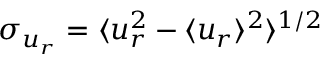<formula> <loc_0><loc_0><loc_500><loc_500>\sigma _ { u _ { r } } = \langle u _ { r } ^ { 2 } - \langle u _ { r } \rangle ^ { 2 } \rangle ^ { 1 / 2 }</formula> 